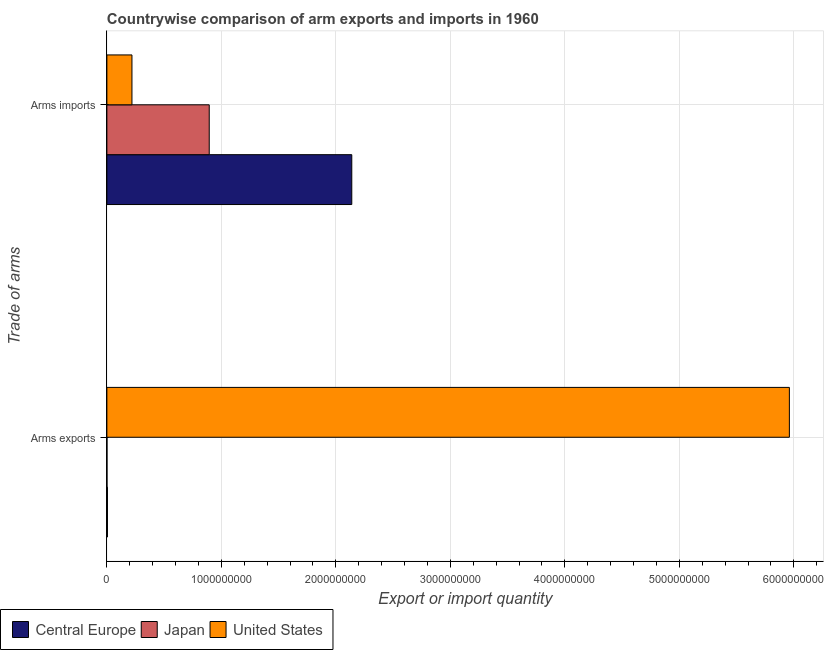How many groups of bars are there?
Ensure brevity in your answer.  2. Are the number of bars on each tick of the Y-axis equal?
Your response must be concise. Yes. How many bars are there on the 2nd tick from the top?
Make the answer very short. 3. How many bars are there on the 2nd tick from the bottom?
Ensure brevity in your answer.  3. What is the label of the 2nd group of bars from the top?
Give a very brief answer. Arms exports. What is the arms exports in Central Europe?
Provide a succinct answer. 5.00e+06. Across all countries, what is the maximum arms exports?
Ensure brevity in your answer.  5.96e+09. Across all countries, what is the minimum arms imports?
Keep it short and to the point. 2.19e+08. What is the total arms exports in the graph?
Your answer should be very brief. 5.97e+09. What is the difference between the arms exports in Central Europe and that in United States?
Offer a very short reply. -5.96e+09. What is the difference between the arms imports in Central Europe and the arms exports in United States?
Ensure brevity in your answer.  -3.82e+09. What is the average arms exports per country?
Give a very brief answer. 1.99e+09. What is the difference between the arms imports and arms exports in United States?
Your answer should be compact. -5.74e+09. In how many countries, is the arms exports greater than 3000000000 ?
Give a very brief answer. 1. Is the arms exports in United States less than that in Central Europe?
Make the answer very short. No. In how many countries, is the arms exports greater than the average arms exports taken over all countries?
Ensure brevity in your answer.  1. What does the 3rd bar from the bottom in Arms exports represents?
Your response must be concise. United States. Are all the bars in the graph horizontal?
Offer a terse response. Yes. How many countries are there in the graph?
Your response must be concise. 3. Does the graph contain grids?
Provide a short and direct response. Yes. How are the legend labels stacked?
Ensure brevity in your answer.  Horizontal. What is the title of the graph?
Keep it short and to the point. Countrywise comparison of arm exports and imports in 1960. Does "Chad" appear as one of the legend labels in the graph?
Keep it short and to the point. No. What is the label or title of the X-axis?
Keep it short and to the point. Export or import quantity. What is the label or title of the Y-axis?
Ensure brevity in your answer.  Trade of arms. What is the Export or import quantity in Central Europe in Arms exports?
Provide a succinct answer. 5.00e+06. What is the Export or import quantity of Japan in Arms exports?
Give a very brief answer. 1.00e+06. What is the Export or import quantity of United States in Arms exports?
Keep it short and to the point. 5.96e+09. What is the Export or import quantity in Central Europe in Arms imports?
Provide a short and direct response. 2.14e+09. What is the Export or import quantity in Japan in Arms imports?
Provide a short and direct response. 8.94e+08. What is the Export or import quantity of United States in Arms imports?
Make the answer very short. 2.19e+08. Across all Trade of arms, what is the maximum Export or import quantity of Central Europe?
Keep it short and to the point. 2.14e+09. Across all Trade of arms, what is the maximum Export or import quantity of Japan?
Your answer should be very brief. 8.94e+08. Across all Trade of arms, what is the maximum Export or import quantity of United States?
Provide a short and direct response. 5.96e+09. Across all Trade of arms, what is the minimum Export or import quantity of Central Europe?
Offer a terse response. 5.00e+06. Across all Trade of arms, what is the minimum Export or import quantity in United States?
Your answer should be compact. 2.19e+08. What is the total Export or import quantity of Central Europe in the graph?
Provide a succinct answer. 2.14e+09. What is the total Export or import quantity in Japan in the graph?
Provide a short and direct response. 8.95e+08. What is the total Export or import quantity of United States in the graph?
Your response must be concise. 6.18e+09. What is the difference between the Export or import quantity in Central Europe in Arms exports and that in Arms imports?
Offer a very short reply. -2.13e+09. What is the difference between the Export or import quantity of Japan in Arms exports and that in Arms imports?
Offer a terse response. -8.93e+08. What is the difference between the Export or import quantity of United States in Arms exports and that in Arms imports?
Offer a terse response. 5.74e+09. What is the difference between the Export or import quantity in Central Europe in Arms exports and the Export or import quantity in Japan in Arms imports?
Provide a short and direct response. -8.89e+08. What is the difference between the Export or import quantity in Central Europe in Arms exports and the Export or import quantity in United States in Arms imports?
Make the answer very short. -2.14e+08. What is the difference between the Export or import quantity in Japan in Arms exports and the Export or import quantity in United States in Arms imports?
Ensure brevity in your answer.  -2.18e+08. What is the average Export or import quantity in Central Europe per Trade of arms?
Provide a short and direct response. 1.07e+09. What is the average Export or import quantity of Japan per Trade of arms?
Your response must be concise. 4.48e+08. What is the average Export or import quantity of United States per Trade of arms?
Provide a short and direct response. 3.09e+09. What is the difference between the Export or import quantity in Central Europe and Export or import quantity in United States in Arms exports?
Offer a terse response. -5.96e+09. What is the difference between the Export or import quantity in Japan and Export or import quantity in United States in Arms exports?
Offer a terse response. -5.96e+09. What is the difference between the Export or import quantity in Central Europe and Export or import quantity in Japan in Arms imports?
Give a very brief answer. 1.24e+09. What is the difference between the Export or import quantity of Central Europe and Export or import quantity of United States in Arms imports?
Provide a succinct answer. 1.92e+09. What is the difference between the Export or import quantity in Japan and Export or import quantity in United States in Arms imports?
Provide a succinct answer. 6.75e+08. What is the ratio of the Export or import quantity of Central Europe in Arms exports to that in Arms imports?
Make the answer very short. 0. What is the ratio of the Export or import quantity of Japan in Arms exports to that in Arms imports?
Offer a terse response. 0. What is the ratio of the Export or import quantity in United States in Arms exports to that in Arms imports?
Ensure brevity in your answer.  27.22. What is the difference between the highest and the second highest Export or import quantity in Central Europe?
Provide a short and direct response. 2.13e+09. What is the difference between the highest and the second highest Export or import quantity of Japan?
Your response must be concise. 8.93e+08. What is the difference between the highest and the second highest Export or import quantity of United States?
Ensure brevity in your answer.  5.74e+09. What is the difference between the highest and the lowest Export or import quantity of Central Europe?
Give a very brief answer. 2.13e+09. What is the difference between the highest and the lowest Export or import quantity in Japan?
Make the answer very short. 8.93e+08. What is the difference between the highest and the lowest Export or import quantity in United States?
Your answer should be compact. 5.74e+09. 